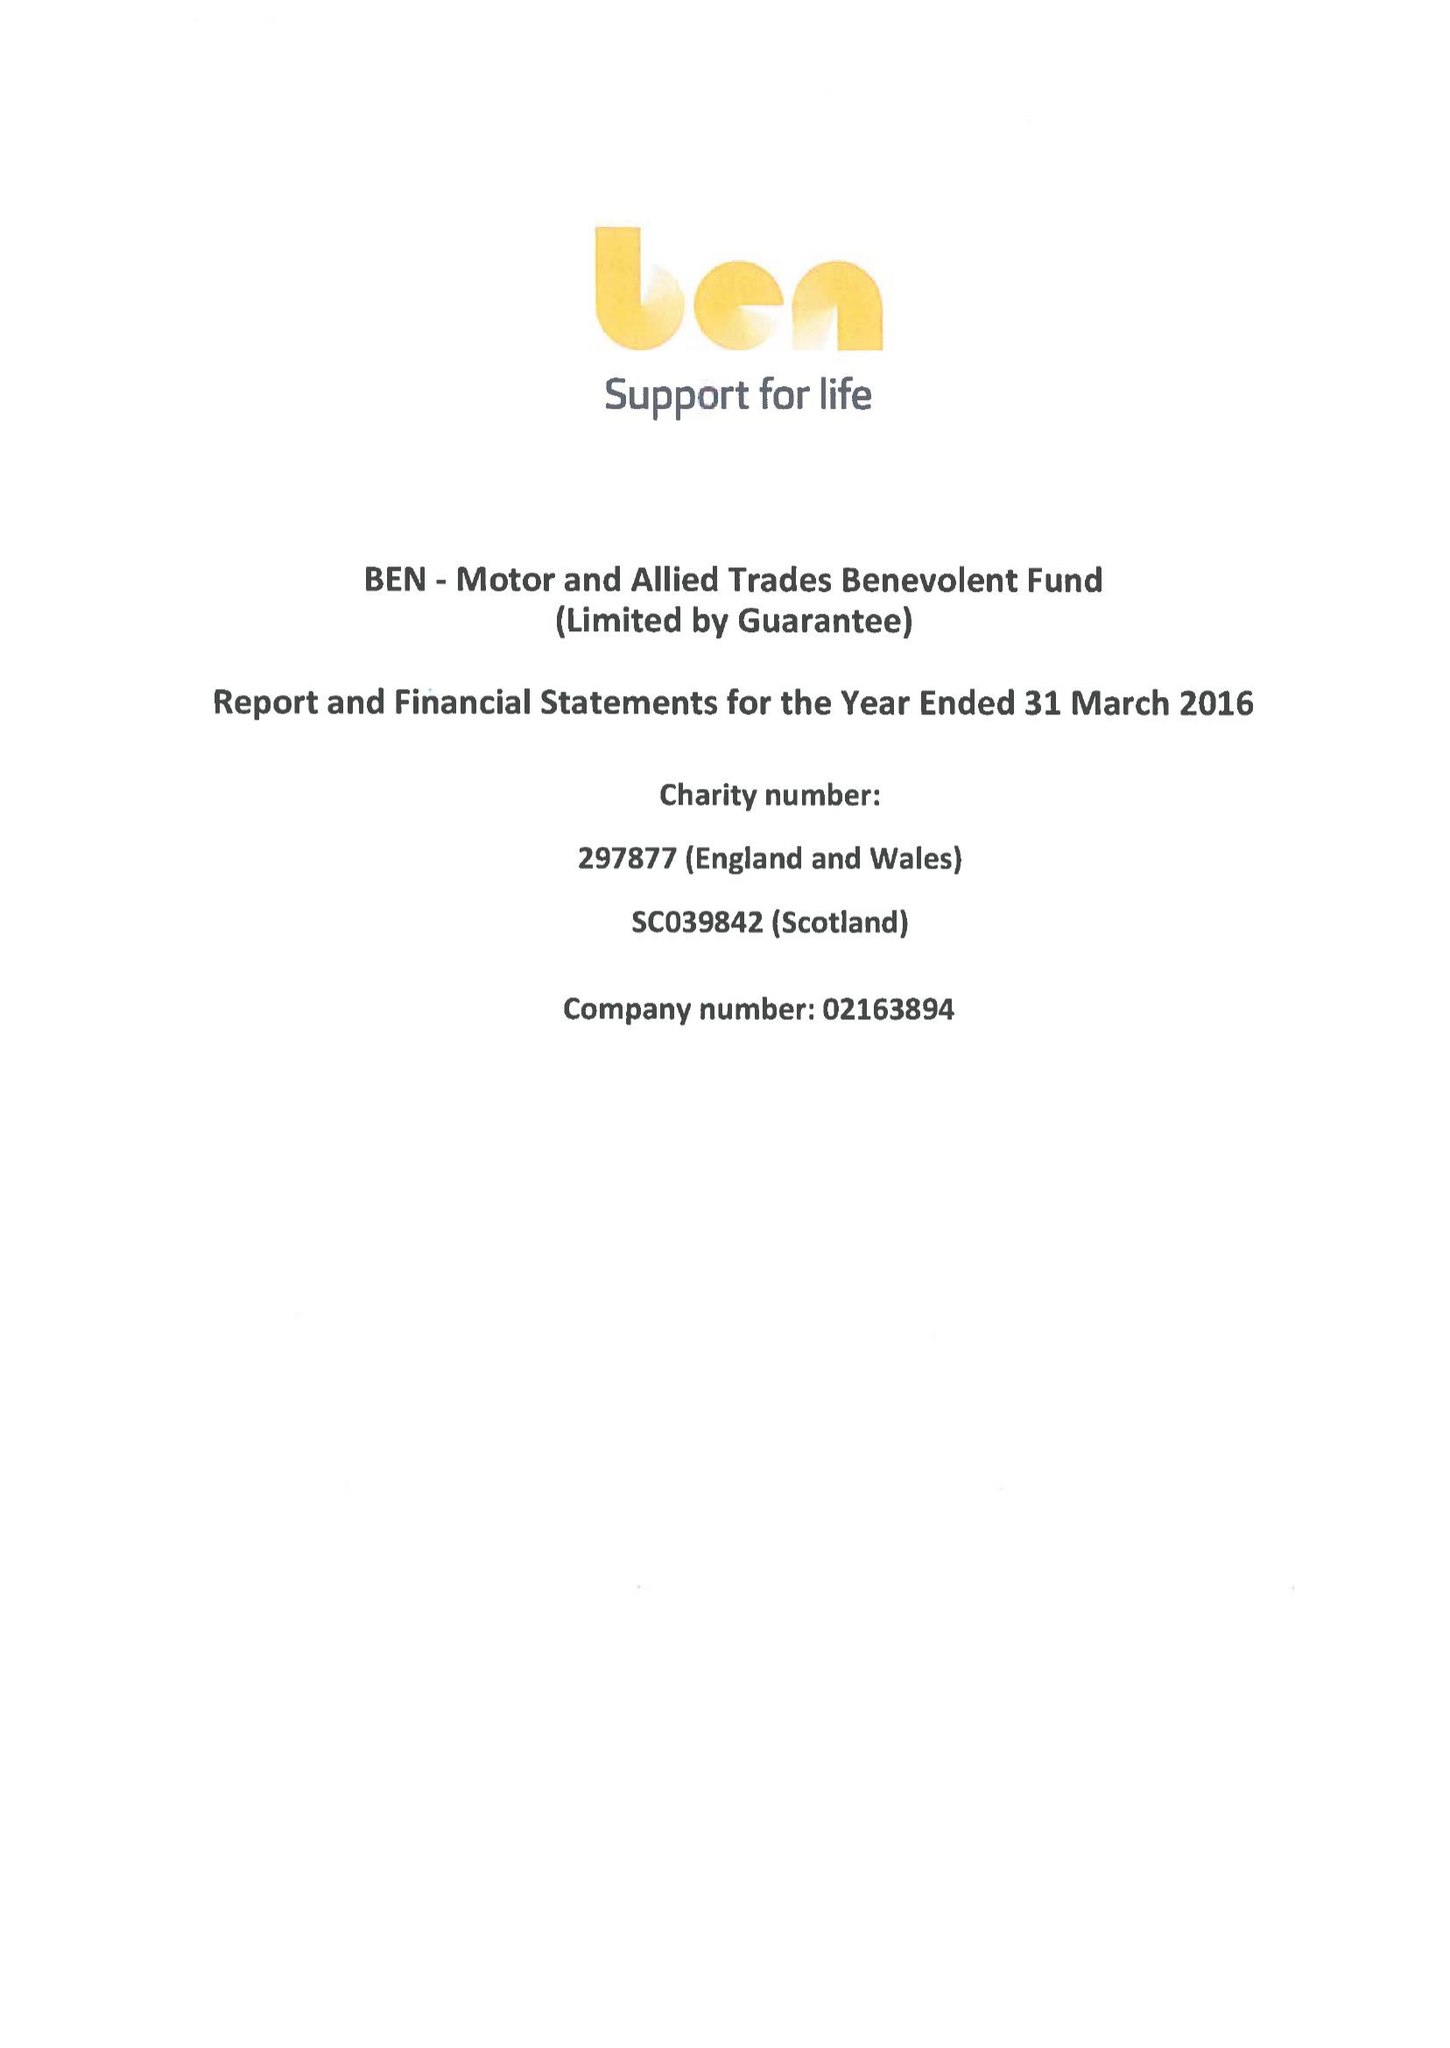What is the value for the income_annually_in_british_pounds?
Answer the question using a single word or phrase. 32288000.00 